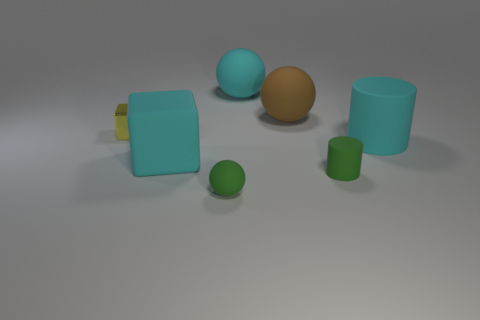Is the large cylinder the same color as the big cube?
Make the answer very short. Yes. What number of other objects are the same color as the big matte cylinder?
Your response must be concise. 2. Is there a tiny cylinder made of the same material as the large cube?
Offer a very short reply. Yes. There is a ball that is the same size as the brown thing; what is it made of?
Offer a terse response. Rubber. How big is the object that is both to the left of the small green sphere and right of the tiny shiny block?
Provide a succinct answer. Large. What is the color of the big thing that is both in front of the yellow metallic thing and to the right of the small matte sphere?
Your response must be concise. Cyan. Is the number of big objects that are behind the brown object less than the number of rubber things that are right of the large cyan rubber sphere?
Ensure brevity in your answer.  Yes. What number of brown matte things are the same shape as the small yellow thing?
Your answer should be compact. 0. There is a brown sphere that is the same material as the large cyan sphere; what is its size?
Ensure brevity in your answer.  Large. The tiny thing to the left of the rubber ball that is to the left of the large cyan rubber ball is what color?
Give a very brief answer. Yellow. 